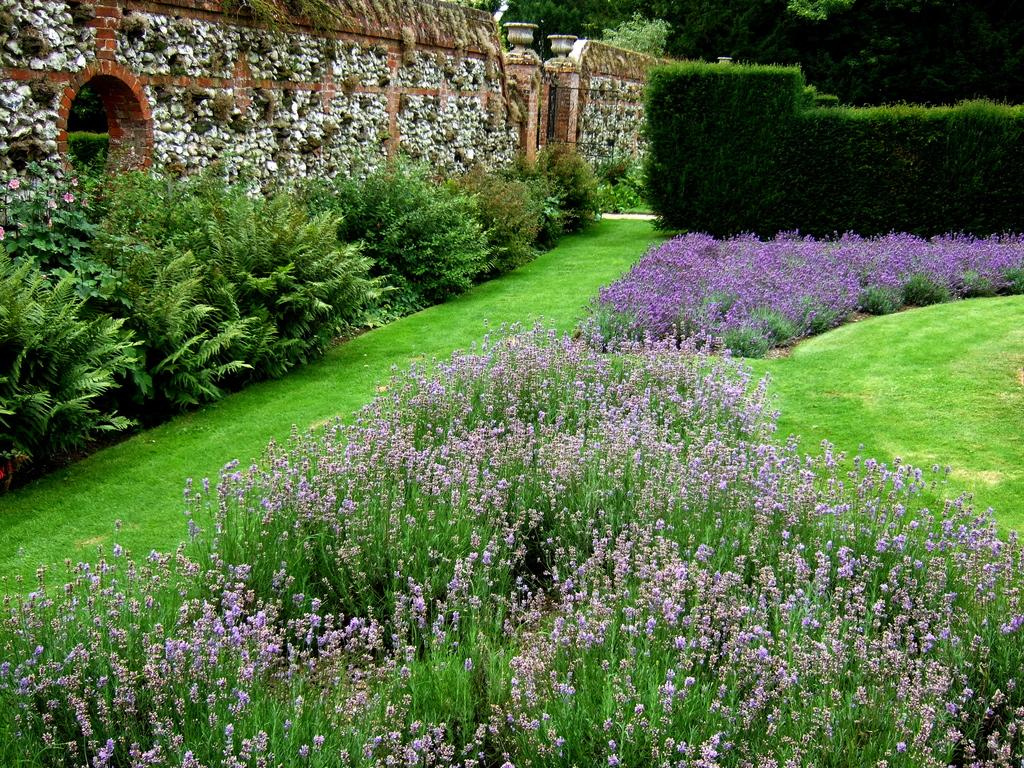What type of vegetation is present at the bottom of the image? There is grass, plants, and flowers at the bottom of the image. What can be seen in the background of the image? There is a wall, a window, a gate, plants, and trees in the background of the image. What type of curve can be seen in the image? There is no curve present in the image. Is there a tank visible in the image? No, there is no tank present in the image. 